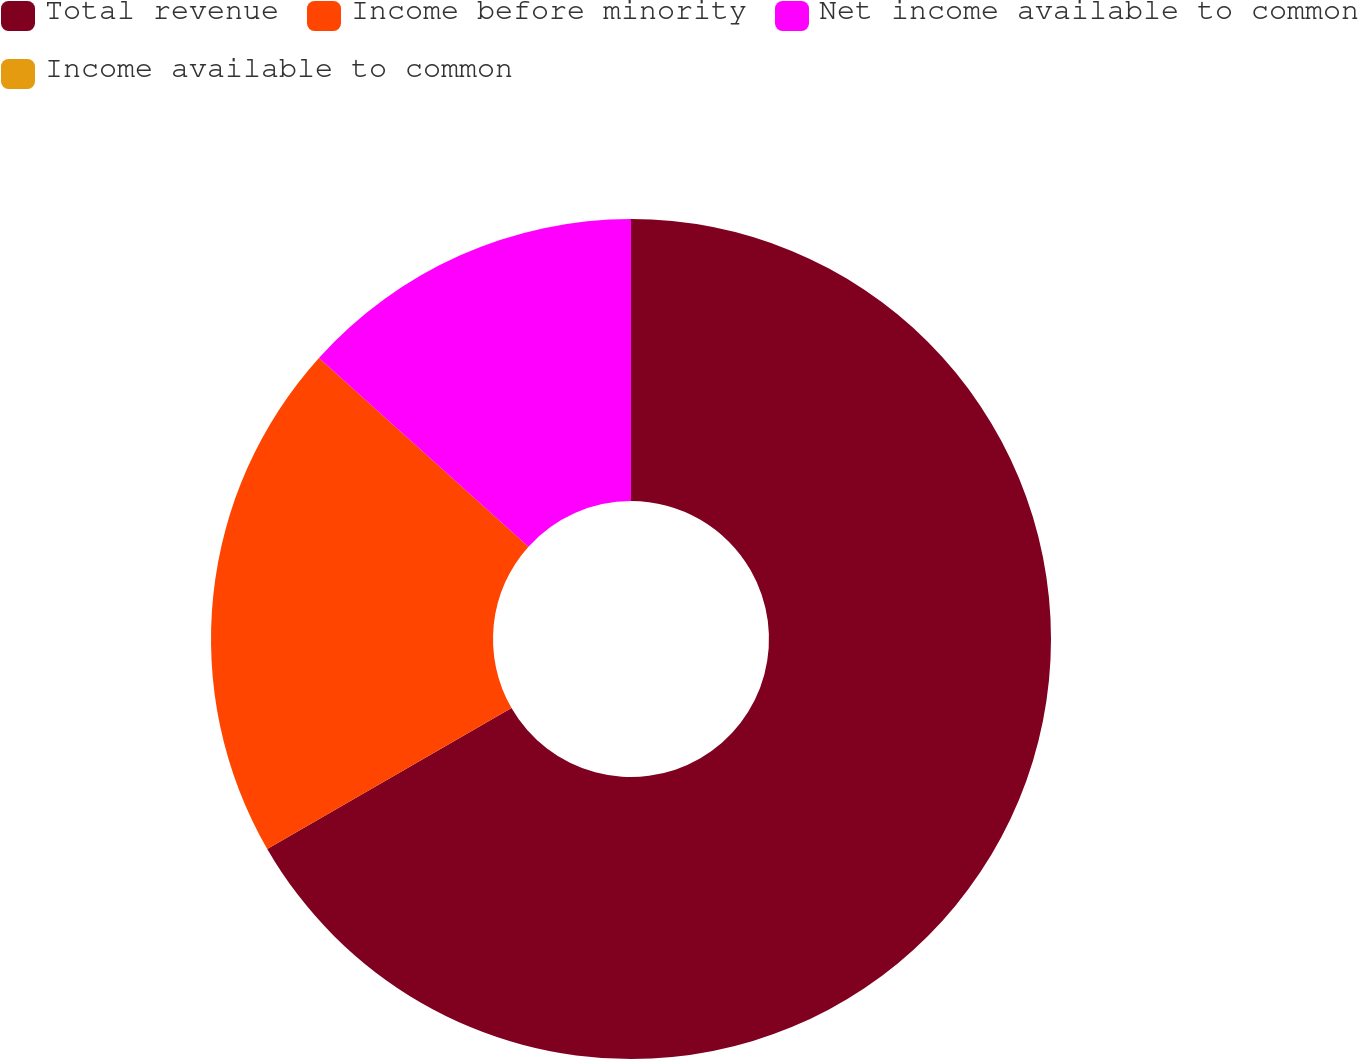<chart> <loc_0><loc_0><loc_500><loc_500><pie_chart><fcel>Total revenue<fcel>Income before minority<fcel>Net income available to common<fcel>Income available to common<nl><fcel>66.67%<fcel>20.0%<fcel>13.33%<fcel>0.0%<nl></chart> 